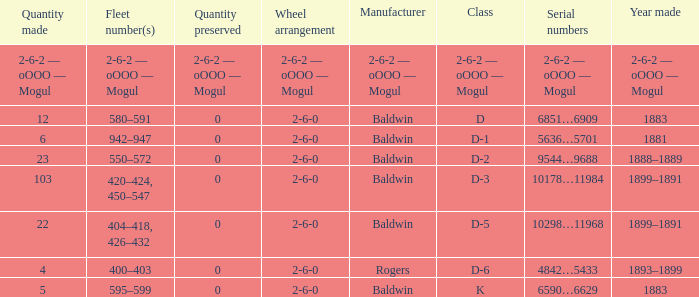Can you parse all the data within this table? {'header': ['Quantity made', 'Fleet number(s)', 'Quantity preserved', 'Wheel arrangement', 'Manufacturer', 'Class', 'Serial numbers', 'Year made'], 'rows': [['2-6-2 — oOOO — Mogul', '2-6-2 — oOOO — Mogul', '2-6-2 — oOOO — Mogul', '2-6-2 — oOOO — Mogul', '2-6-2 — oOOO — Mogul', '2-6-2 — oOOO — Mogul', '2-6-2 — oOOO — Mogul', '2-6-2 — oOOO — Mogul'], ['12', '580–591', '0', '2-6-0', 'Baldwin', 'D', '6851…6909', '1883'], ['6', '942–947', '0', '2-6-0', 'Baldwin', 'D-1', '5636…5701', '1881'], ['23', '550–572', '0', '2-6-0', 'Baldwin', 'D-2', '9544…9688', '1888–1889'], ['103', '420–424, 450–547', '0', '2-6-0', 'Baldwin', 'D-3', '10178…11984', '1899–1891'], ['22', '404–418, 426–432', '0', '2-6-0', 'Baldwin', 'D-5', '10298…11968', '1899–1891'], ['4', '400–403', '0', '2-6-0', 'Rogers', 'D-6', '4842…5433', '1893–1899'], ['5', '595–599', '0', '2-6-0', 'Baldwin', 'K', '6590…6629', '1883']]} What is the quantity made when the class is d-2? 23.0. 